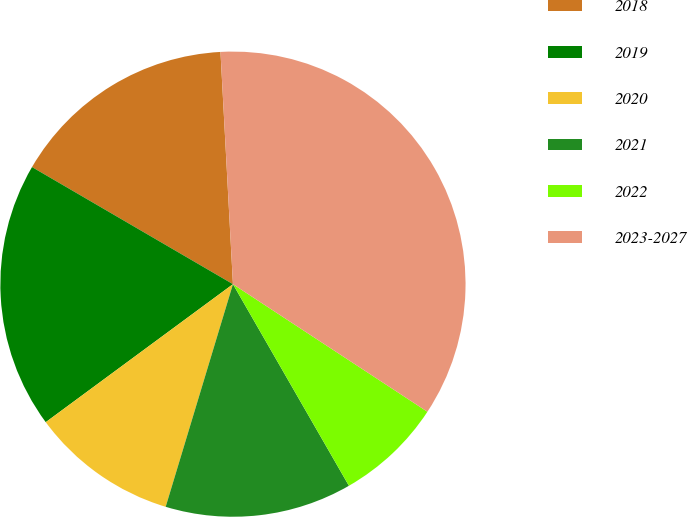<chart> <loc_0><loc_0><loc_500><loc_500><pie_chart><fcel>2018<fcel>2019<fcel>2020<fcel>2021<fcel>2022<fcel>2023-2027<nl><fcel>15.75%<fcel>18.51%<fcel>10.22%<fcel>12.98%<fcel>7.45%<fcel>35.1%<nl></chart> 